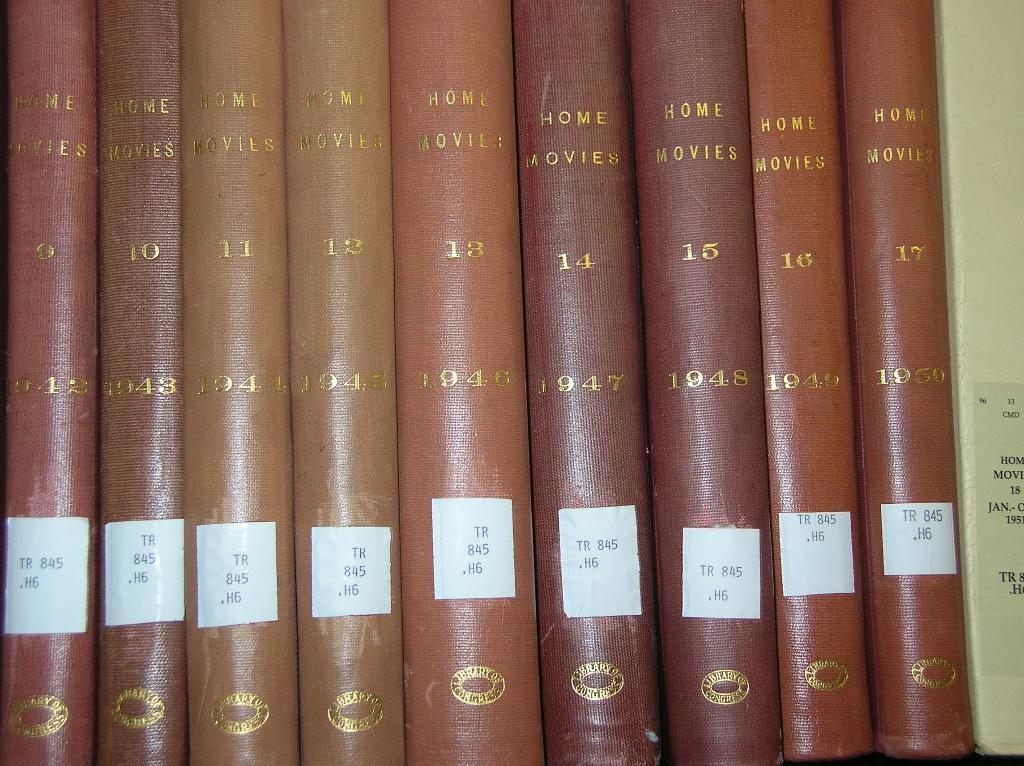<image>
Present a compact description of the photo's key features. the book that has the number 11 on it 